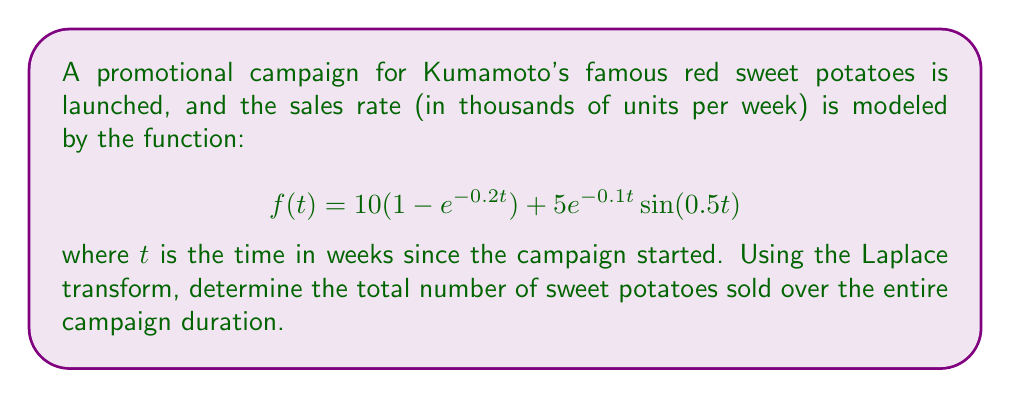Solve this math problem. To solve this problem, we'll follow these steps:

1) First, we need to find the Laplace transform of $f(t)$. Let's call it $F(s)$.

2) The total number of sweet potatoes sold is the integral of $f(t)$ from 0 to infinity, which is equivalent to $F(0)$ in the s-domain.

Step 1: Finding the Laplace transform

The Laplace transform of $f(t)$ is:

$$F(s) = \mathcal{L}\{10(1 - e^{-0.2t})\} + \mathcal{L}\{5e^{-0.1t}\sin(0.5t)\}$$

For the first term:
$$\mathcal{L}\{10(1 - e^{-0.2t})\} = \frac{10}{s} - \frac{10}{s+0.2}$$

For the second term, we use the Laplace transform of $e^{at}\sin(bt)$:
$$\mathcal{L}\{5e^{-0.1t}\sin(0.5t)\} = \frac{5 \cdot 0.5}{(s+0.1)^2 + 0.5^2}$$

Therefore,
$$F(s) = \frac{10}{s} - \frac{10}{s+0.2} + \frac{2.5}{(s+0.1)^2 + 0.25}$$

Step 2: Finding the total number of sweet potatoes sold

The total number of sweet potatoes sold is $F(0)$:

$$F(0) = \lim_{s \to 0} F(s) = \lim_{s \to 0} \left(\frac{10}{s} - \frac{10}{s+0.2} + \frac{2.5}{(s+0.1)^2 + 0.25}\right)$$

As $s$ approaches 0:
- $\frac{10}{s}$ approaches infinity
- $\frac{10}{s+0.2}$ approaches 50
- $\frac{2.5}{(s+0.1)^2 + 0.25}$ approaches 10

The infinite term indicates that the total sales over an infinite time period would be infinite. However, we can interpret this result as the campaign being highly successful, with sales continuing to grow over time.
Answer: The total number of sweet potatoes sold over the entire campaign duration approaches infinity, indicating a highly successful and long-lasting campaign effect on sales. 